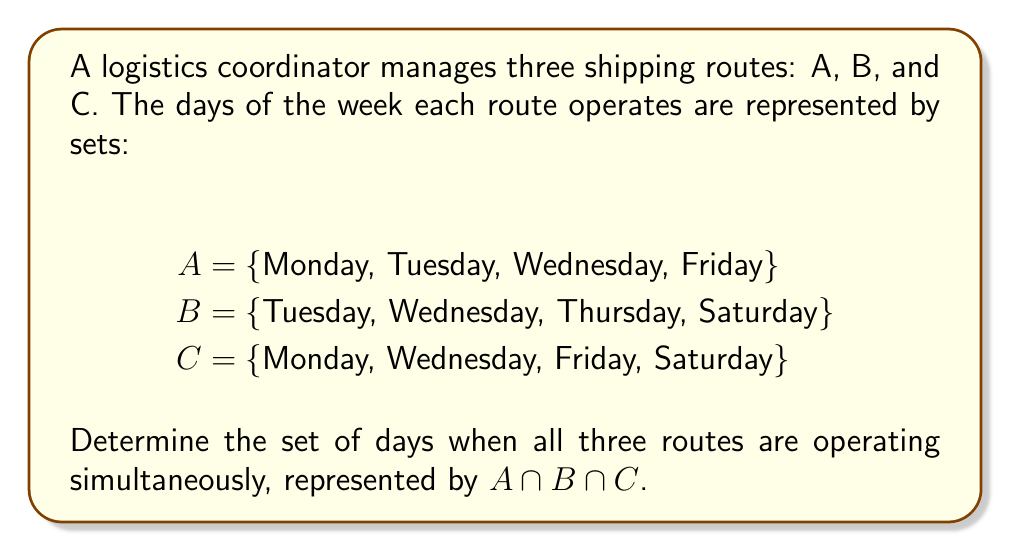What is the answer to this math problem? To find the intersection of multiple sets, we need to identify the elements that are common to all sets. Let's approach this step-by-step:

1. First, let's list out each set:
   A = {Monday, Tuesday, Wednesday, Friday}
   B = {Tuesday, Wednesday, Thursday, Saturday}
   C = {Monday, Wednesday, Friday, Saturday}

2. To find $A \cap B \cap C$, we need to identify the days that appear in all three sets.

3. Let's start by finding $A \cap B$:
   A ∩ B = {Tuesday, Wednesday}

4. Now, we need to find the intersection of this result with C:
   (A ∩ B) ∩ C = {Tuesday, Wednesday} ∩ {Monday, Wednesday, Friday, Saturday}

5. The only day that appears in both {Tuesday, Wednesday} and C is Wednesday.

Therefore, $A \cap B \cap C = \{Wednesday\}$

This means that Wednesday is the only day when all three shipping routes are operating simultaneously.

In set notation, we can write this as:

$$A \cap B \cap C = \{Wednesday\}$$
Answer: $\{Wednesday\}$ 